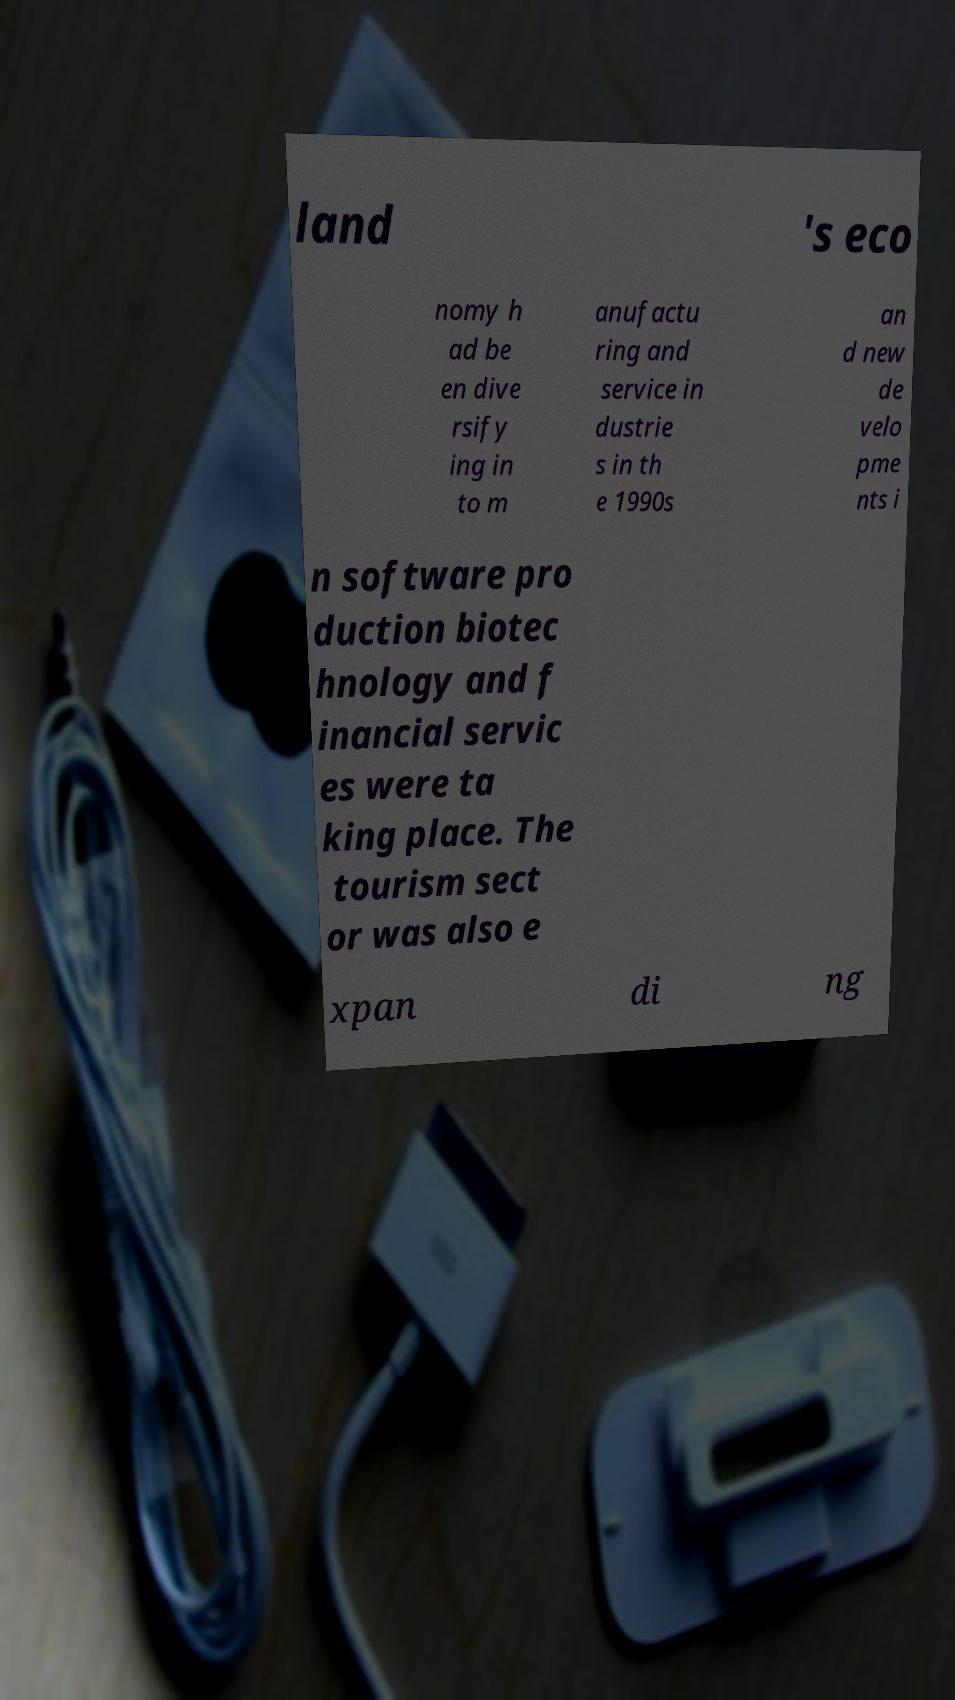Please identify and transcribe the text found in this image. land 's eco nomy h ad be en dive rsify ing in to m anufactu ring and service in dustrie s in th e 1990s an d new de velo pme nts i n software pro duction biotec hnology and f inancial servic es were ta king place. The tourism sect or was also e xpan di ng 